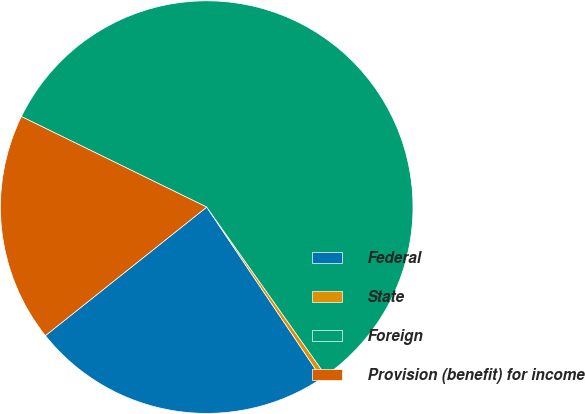Convert chart to OTSL. <chart><loc_0><loc_0><loc_500><loc_500><pie_chart><fcel>Federal<fcel>State<fcel>Foreign<fcel>Provision (benefit) for income<nl><fcel>23.7%<fcel>0.38%<fcel>57.98%<fcel>17.94%<nl></chart> 